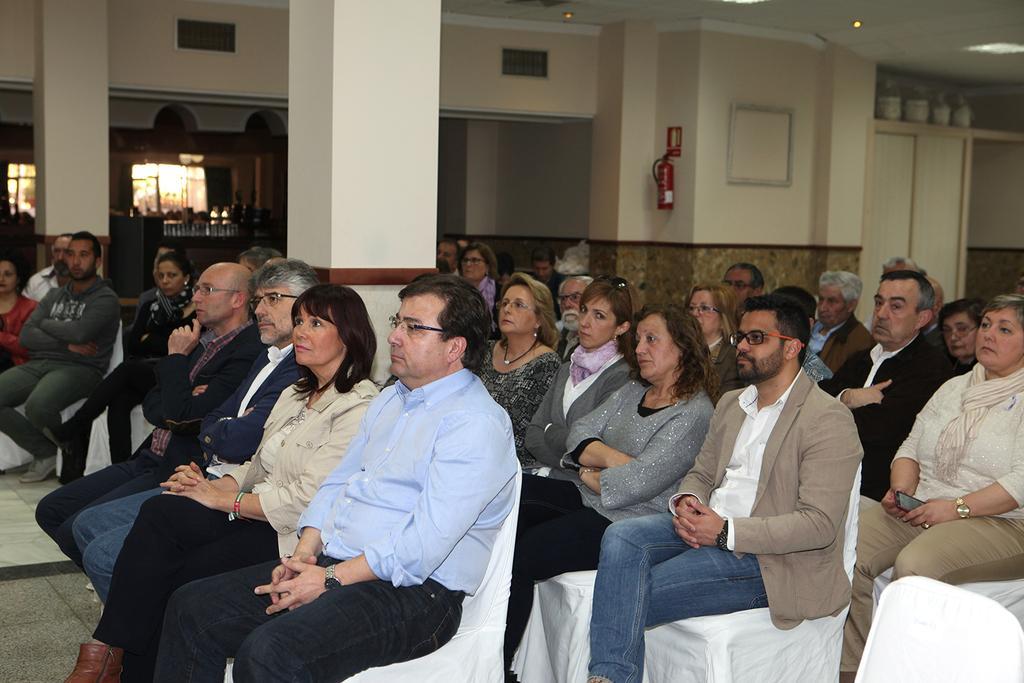Describe this image in one or two sentences. There are groups of people sitting on the chairs. These are the pillars. I can see a fire extinguisher, which is attached to the wall. This looks like a door. In the background, I think these are the windows. 